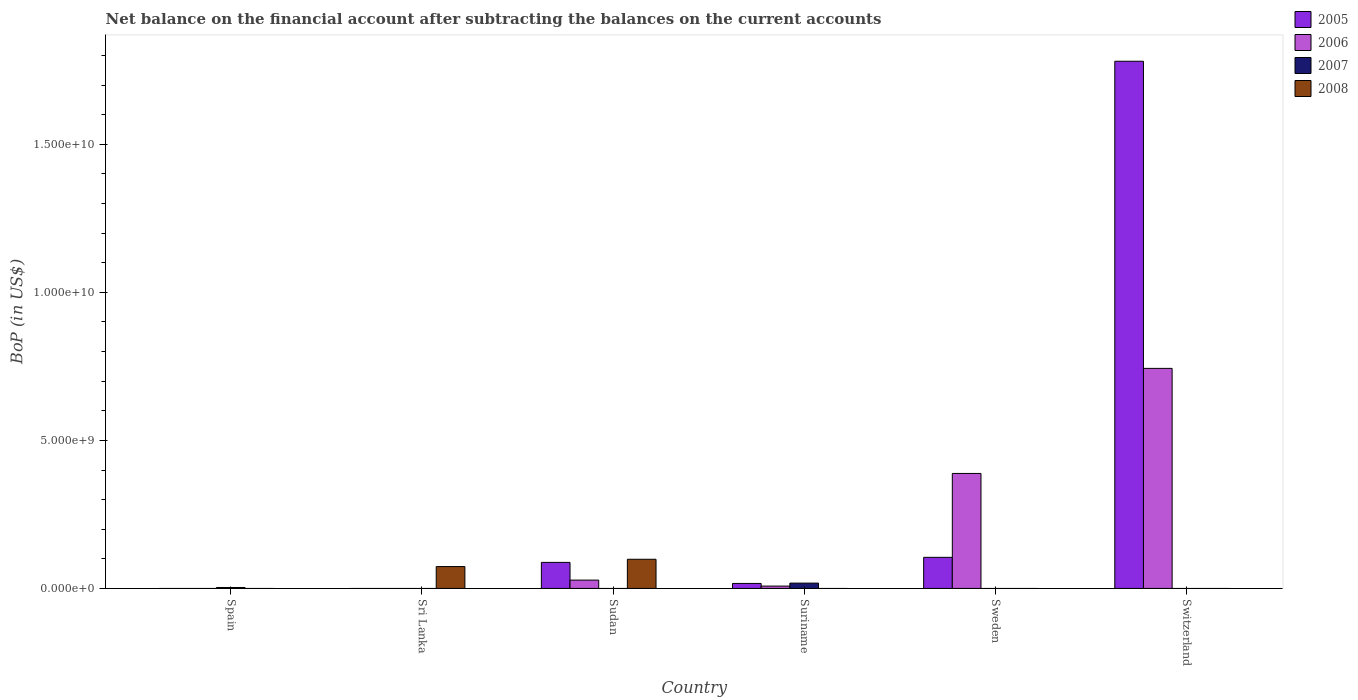How many different coloured bars are there?
Offer a terse response. 4. Are the number of bars per tick equal to the number of legend labels?
Provide a short and direct response. No. How many bars are there on the 6th tick from the left?
Your answer should be very brief. 2. What is the Balance of Payments in 2007 in Spain?
Keep it short and to the point. 3.16e+07. Across all countries, what is the maximum Balance of Payments in 2005?
Ensure brevity in your answer.  1.78e+1. In which country was the Balance of Payments in 2006 maximum?
Your response must be concise. Switzerland. What is the total Balance of Payments in 2005 in the graph?
Your response must be concise. 1.99e+1. What is the difference between the Balance of Payments in 2007 in Spain and that in Suriname?
Offer a terse response. -1.48e+08. What is the difference between the Balance of Payments in 2005 in Sudan and the Balance of Payments in 2006 in Switzerland?
Your response must be concise. -6.55e+09. What is the average Balance of Payments in 2008 per country?
Give a very brief answer. 2.87e+08. What is the difference between the Balance of Payments of/in 2006 and Balance of Payments of/in 2005 in Sweden?
Make the answer very short. 2.83e+09. In how many countries, is the Balance of Payments in 2007 greater than 3000000000 US$?
Offer a very short reply. 0. Is the Balance of Payments in 2008 in Sri Lanka less than that in Sudan?
Provide a short and direct response. Yes. Is the difference between the Balance of Payments in 2006 in Sudan and Suriname greater than the difference between the Balance of Payments in 2005 in Sudan and Suriname?
Your response must be concise. No. What is the difference between the highest and the second highest Balance of Payments in 2005?
Make the answer very short. 1.70e+08. What is the difference between the highest and the lowest Balance of Payments in 2005?
Provide a succinct answer. 1.78e+1. In how many countries, is the Balance of Payments in 2008 greater than the average Balance of Payments in 2008 taken over all countries?
Make the answer very short. 2. Is it the case that in every country, the sum of the Balance of Payments in 2007 and Balance of Payments in 2005 is greater than the sum of Balance of Payments in 2008 and Balance of Payments in 2006?
Provide a short and direct response. No. Are all the bars in the graph horizontal?
Offer a very short reply. No. How many countries are there in the graph?
Provide a short and direct response. 6. What is the difference between two consecutive major ticks on the Y-axis?
Your answer should be very brief. 5.00e+09. Are the values on the major ticks of Y-axis written in scientific E-notation?
Provide a short and direct response. Yes. Does the graph contain any zero values?
Provide a succinct answer. Yes. Does the graph contain grids?
Provide a succinct answer. No. What is the title of the graph?
Your answer should be very brief. Net balance on the financial account after subtracting the balances on the current accounts. Does "1983" appear as one of the legend labels in the graph?
Your answer should be very brief. No. What is the label or title of the X-axis?
Offer a terse response. Country. What is the label or title of the Y-axis?
Give a very brief answer. BoP (in US$). What is the BoP (in US$) of 2005 in Spain?
Your answer should be very brief. 0. What is the BoP (in US$) of 2007 in Spain?
Offer a terse response. 3.16e+07. What is the BoP (in US$) of 2008 in Spain?
Offer a terse response. 0. What is the BoP (in US$) in 2005 in Sri Lanka?
Make the answer very short. 0. What is the BoP (in US$) of 2006 in Sri Lanka?
Give a very brief answer. 0. What is the BoP (in US$) of 2008 in Sri Lanka?
Provide a short and direct response. 7.39e+08. What is the BoP (in US$) in 2005 in Sudan?
Your answer should be compact. 8.80e+08. What is the BoP (in US$) in 2006 in Sudan?
Your response must be concise. 2.82e+08. What is the BoP (in US$) of 2007 in Sudan?
Provide a succinct answer. 0. What is the BoP (in US$) of 2008 in Sudan?
Give a very brief answer. 9.86e+08. What is the BoP (in US$) of 2005 in Suriname?
Your response must be concise. 1.69e+08. What is the BoP (in US$) in 2006 in Suriname?
Offer a terse response. 7.95e+07. What is the BoP (in US$) of 2007 in Suriname?
Provide a succinct answer. 1.80e+08. What is the BoP (in US$) in 2005 in Sweden?
Offer a very short reply. 1.05e+09. What is the BoP (in US$) in 2006 in Sweden?
Offer a very short reply. 3.88e+09. What is the BoP (in US$) in 2005 in Switzerland?
Provide a short and direct response. 1.78e+1. What is the BoP (in US$) in 2006 in Switzerland?
Ensure brevity in your answer.  7.43e+09. What is the BoP (in US$) of 2007 in Switzerland?
Your answer should be very brief. 0. Across all countries, what is the maximum BoP (in US$) in 2005?
Your response must be concise. 1.78e+1. Across all countries, what is the maximum BoP (in US$) of 2006?
Make the answer very short. 7.43e+09. Across all countries, what is the maximum BoP (in US$) of 2007?
Offer a terse response. 1.80e+08. Across all countries, what is the maximum BoP (in US$) in 2008?
Give a very brief answer. 9.86e+08. Across all countries, what is the minimum BoP (in US$) in 2005?
Offer a terse response. 0. Across all countries, what is the minimum BoP (in US$) in 2006?
Offer a terse response. 0. Across all countries, what is the minimum BoP (in US$) of 2007?
Your answer should be compact. 0. Across all countries, what is the minimum BoP (in US$) in 2008?
Provide a succinct answer. 0. What is the total BoP (in US$) of 2005 in the graph?
Your answer should be very brief. 1.99e+1. What is the total BoP (in US$) in 2006 in the graph?
Keep it short and to the point. 1.17e+1. What is the total BoP (in US$) of 2007 in the graph?
Your answer should be very brief. 2.11e+08. What is the total BoP (in US$) of 2008 in the graph?
Provide a succinct answer. 1.72e+09. What is the difference between the BoP (in US$) in 2007 in Spain and that in Suriname?
Provide a short and direct response. -1.48e+08. What is the difference between the BoP (in US$) in 2008 in Sri Lanka and that in Sudan?
Keep it short and to the point. -2.47e+08. What is the difference between the BoP (in US$) in 2005 in Sudan and that in Suriname?
Make the answer very short. 7.11e+08. What is the difference between the BoP (in US$) in 2006 in Sudan and that in Suriname?
Your response must be concise. 2.02e+08. What is the difference between the BoP (in US$) of 2005 in Sudan and that in Sweden?
Give a very brief answer. -1.70e+08. What is the difference between the BoP (in US$) in 2006 in Sudan and that in Sweden?
Provide a short and direct response. -3.60e+09. What is the difference between the BoP (in US$) of 2005 in Sudan and that in Switzerland?
Offer a very short reply. -1.69e+1. What is the difference between the BoP (in US$) of 2006 in Sudan and that in Switzerland?
Your response must be concise. -7.15e+09. What is the difference between the BoP (in US$) of 2005 in Suriname and that in Sweden?
Make the answer very short. -8.82e+08. What is the difference between the BoP (in US$) of 2006 in Suriname and that in Sweden?
Give a very brief answer. -3.80e+09. What is the difference between the BoP (in US$) of 2005 in Suriname and that in Switzerland?
Provide a succinct answer. -1.76e+1. What is the difference between the BoP (in US$) of 2006 in Suriname and that in Switzerland?
Provide a short and direct response. -7.35e+09. What is the difference between the BoP (in US$) in 2005 in Sweden and that in Switzerland?
Make the answer very short. -1.68e+1. What is the difference between the BoP (in US$) in 2006 in Sweden and that in Switzerland?
Give a very brief answer. -3.55e+09. What is the difference between the BoP (in US$) of 2007 in Spain and the BoP (in US$) of 2008 in Sri Lanka?
Make the answer very short. -7.07e+08. What is the difference between the BoP (in US$) of 2007 in Spain and the BoP (in US$) of 2008 in Sudan?
Give a very brief answer. -9.54e+08. What is the difference between the BoP (in US$) of 2005 in Sudan and the BoP (in US$) of 2006 in Suriname?
Ensure brevity in your answer.  8.01e+08. What is the difference between the BoP (in US$) in 2005 in Sudan and the BoP (in US$) in 2007 in Suriname?
Offer a terse response. 7.00e+08. What is the difference between the BoP (in US$) of 2006 in Sudan and the BoP (in US$) of 2007 in Suriname?
Your answer should be very brief. 1.02e+08. What is the difference between the BoP (in US$) in 2005 in Sudan and the BoP (in US$) in 2006 in Sweden?
Provide a short and direct response. -3.00e+09. What is the difference between the BoP (in US$) in 2005 in Sudan and the BoP (in US$) in 2006 in Switzerland?
Offer a very short reply. -6.55e+09. What is the difference between the BoP (in US$) of 2005 in Suriname and the BoP (in US$) of 2006 in Sweden?
Make the answer very short. -3.72e+09. What is the difference between the BoP (in US$) of 2005 in Suriname and the BoP (in US$) of 2006 in Switzerland?
Ensure brevity in your answer.  -7.26e+09. What is the difference between the BoP (in US$) in 2005 in Sweden and the BoP (in US$) in 2006 in Switzerland?
Offer a very short reply. -6.38e+09. What is the average BoP (in US$) of 2005 per country?
Give a very brief answer. 3.32e+09. What is the average BoP (in US$) of 2006 per country?
Give a very brief answer. 1.95e+09. What is the average BoP (in US$) of 2007 per country?
Your response must be concise. 3.52e+07. What is the average BoP (in US$) of 2008 per country?
Give a very brief answer. 2.87e+08. What is the difference between the BoP (in US$) in 2005 and BoP (in US$) in 2006 in Sudan?
Give a very brief answer. 5.98e+08. What is the difference between the BoP (in US$) of 2005 and BoP (in US$) of 2008 in Sudan?
Give a very brief answer. -1.05e+08. What is the difference between the BoP (in US$) in 2006 and BoP (in US$) in 2008 in Sudan?
Your answer should be very brief. -7.04e+08. What is the difference between the BoP (in US$) in 2005 and BoP (in US$) in 2006 in Suriname?
Offer a very short reply. 8.93e+07. What is the difference between the BoP (in US$) of 2005 and BoP (in US$) of 2007 in Suriname?
Offer a terse response. -1.10e+07. What is the difference between the BoP (in US$) of 2006 and BoP (in US$) of 2007 in Suriname?
Offer a terse response. -1.00e+08. What is the difference between the BoP (in US$) in 2005 and BoP (in US$) in 2006 in Sweden?
Your answer should be compact. -2.83e+09. What is the difference between the BoP (in US$) in 2005 and BoP (in US$) in 2006 in Switzerland?
Your answer should be very brief. 1.04e+1. What is the ratio of the BoP (in US$) in 2007 in Spain to that in Suriname?
Provide a succinct answer. 0.18. What is the ratio of the BoP (in US$) in 2008 in Sri Lanka to that in Sudan?
Ensure brevity in your answer.  0.75. What is the ratio of the BoP (in US$) in 2005 in Sudan to that in Suriname?
Provide a short and direct response. 5.21. What is the ratio of the BoP (in US$) in 2006 in Sudan to that in Suriname?
Ensure brevity in your answer.  3.54. What is the ratio of the BoP (in US$) of 2005 in Sudan to that in Sweden?
Your response must be concise. 0.84. What is the ratio of the BoP (in US$) in 2006 in Sudan to that in Sweden?
Give a very brief answer. 0.07. What is the ratio of the BoP (in US$) of 2005 in Sudan to that in Switzerland?
Offer a terse response. 0.05. What is the ratio of the BoP (in US$) in 2006 in Sudan to that in Switzerland?
Your response must be concise. 0.04. What is the ratio of the BoP (in US$) of 2005 in Suriname to that in Sweden?
Your answer should be very brief. 0.16. What is the ratio of the BoP (in US$) of 2006 in Suriname to that in Sweden?
Offer a very short reply. 0.02. What is the ratio of the BoP (in US$) in 2005 in Suriname to that in Switzerland?
Your answer should be compact. 0.01. What is the ratio of the BoP (in US$) of 2006 in Suriname to that in Switzerland?
Give a very brief answer. 0.01. What is the ratio of the BoP (in US$) in 2005 in Sweden to that in Switzerland?
Offer a very short reply. 0.06. What is the ratio of the BoP (in US$) of 2006 in Sweden to that in Switzerland?
Offer a terse response. 0.52. What is the difference between the highest and the second highest BoP (in US$) in 2005?
Make the answer very short. 1.68e+1. What is the difference between the highest and the second highest BoP (in US$) of 2006?
Your response must be concise. 3.55e+09. What is the difference between the highest and the lowest BoP (in US$) of 2005?
Provide a succinct answer. 1.78e+1. What is the difference between the highest and the lowest BoP (in US$) of 2006?
Offer a very short reply. 7.43e+09. What is the difference between the highest and the lowest BoP (in US$) of 2007?
Give a very brief answer. 1.80e+08. What is the difference between the highest and the lowest BoP (in US$) of 2008?
Give a very brief answer. 9.86e+08. 